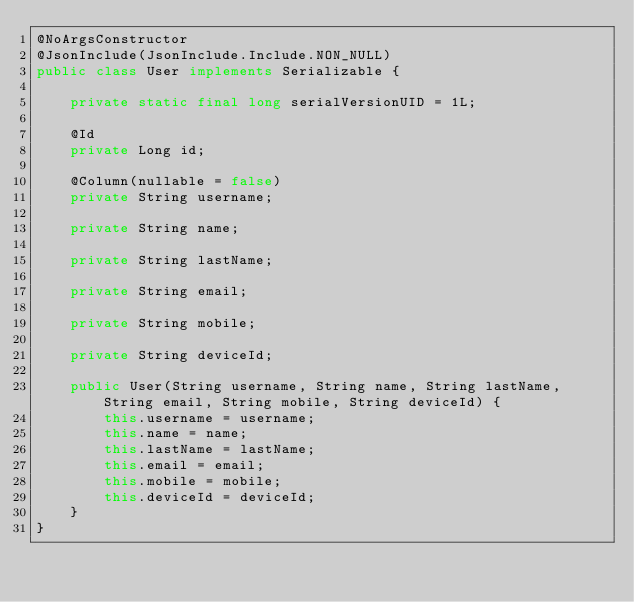Convert code to text. <code><loc_0><loc_0><loc_500><loc_500><_Java_>@NoArgsConstructor
@JsonInclude(JsonInclude.Include.NON_NULL)
public class User implements Serializable {

    private static final long serialVersionUID = 1L;

    @Id
    private Long id;

    @Column(nullable = false)
    private String username;

    private String name;

    private String lastName;

    private String email;

    private String mobile;

    private String deviceId;

    public User(String username, String name, String lastName, String email, String mobile, String deviceId) {
        this.username = username;
        this.name = name;
        this.lastName = lastName;
        this.email = email;
        this.mobile = mobile;
        this.deviceId = deviceId;
    }
}</code> 